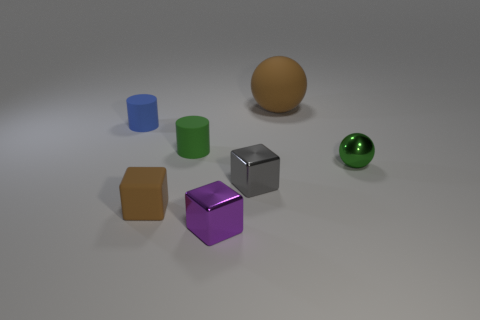There is a brown thing that is the same size as the green ball; what is its shape?
Keep it short and to the point. Cube. What number of tiny objects are the same color as the small metallic ball?
Your answer should be compact. 1. Is the green object that is left of the tiny gray metal cube made of the same material as the big brown object?
Your answer should be compact. Yes. The purple object is what shape?
Provide a succinct answer. Cube. How many yellow objects are either matte things or tiny blocks?
Give a very brief answer. 0. How many other things are made of the same material as the green cylinder?
Provide a succinct answer. 3. There is a brown object behind the tiny green shiny thing; is it the same shape as the small green metal thing?
Make the answer very short. Yes. Are there any small gray metallic blocks?
Your answer should be compact. Yes. Is the number of small gray metallic cubes in front of the blue rubber cylinder greater than the number of big yellow metallic spheres?
Give a very brief answer. Yes. Are there any green shiny balls in front of the blue cylinder?
Offer a terse response. Yes. 